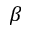Convert formula to latex. <formula><loc_0><loc_0><loc_500><loc_500>\beta</formula> 